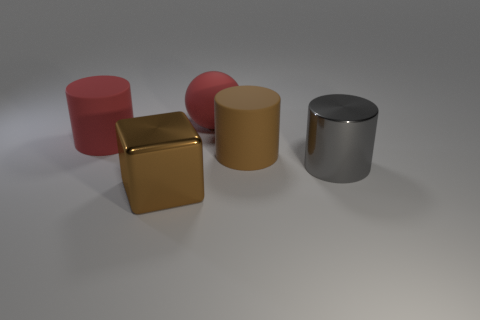Add 3 tiny brown matte blocks. How many objects exist? 8 Subtract all balls. How many objects are left? 4 Subtract 0 green blocks. How many objects are left? 5 Subtract all large brown metallic blocks. Subtract all red matte spheres. How many objects are left? 3 Add 3 gray objects. How many gray objects are left? 4 Add 5 gray shiny cylinders. How many gray shiny cylinders exist? 6 